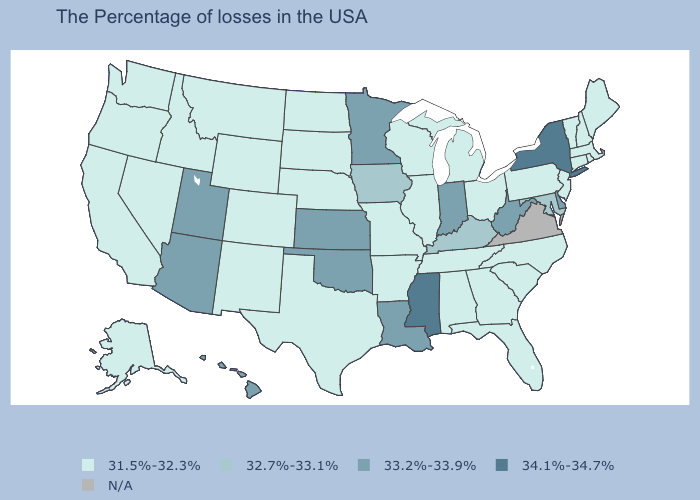Does North Carolina have the highest value in the South?
Keep it brief. No. Does the map have missing data?
Quick response, please. Yes. What is the value of Oklahoma?
Concise answer only. 33.2%-33.9%. Which states have the highest value in the USA?
Concise answer only. New York, Mississippi. Name the states that have a value in the range N/A?
Quick response, please. Virginia. Which states have the highest value in the USA?
Keep it brief. New York, Mississippi. Among the states that border Louisiana , which have the highest value?
Keep it brief. Mississippi. Among the states that border Michigan , which have the highest value?
Answer briefly. Indiana. What is the highest value in states that border Illinois?
Be succinct. 33.2%-33.9%. Name the states that have a value in the range 32.7%-33.1%?
Quick response, please. Maryland, Kentucky, Iowa. What is the value of Missouri?
Short answer required. 31.5%-32.3%. Name the states that have a value in the range 31.5%-32.3%?
Keep it brief. Maine, Massachusetts, Rhode Island, New Hampshire, Vermont, Connecticut, New Jersey, Pennsylvania, North Carolina, South Carolina, Ohio, Florida, Georgia, Michigan, Alabama, Tennessee, Wisconsin, Illinois, Missouri, Arkansas, Nebraska, Texas, South Dakota, North Dakota, Wyoming, Colorado, New Mexico, Montana, Idaho, Nevada, California, Washington, Oregon, Alaska. Does the map have missing data?
Quick response, please. Yes. 